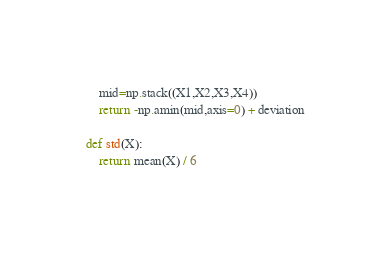<code> <loc_0><loc_0><loc_500><loc_500><_Python_>    mid=np.stack((X1,X2,X3,X4)) 
    return -np.amin(mid,axis=0) + deviation

def std(X): 
    return mean(X) / 6</code> 